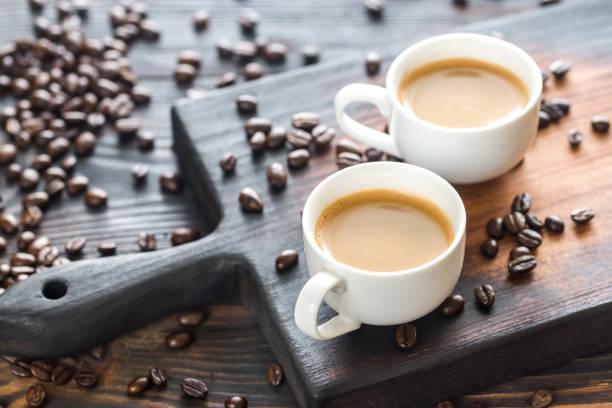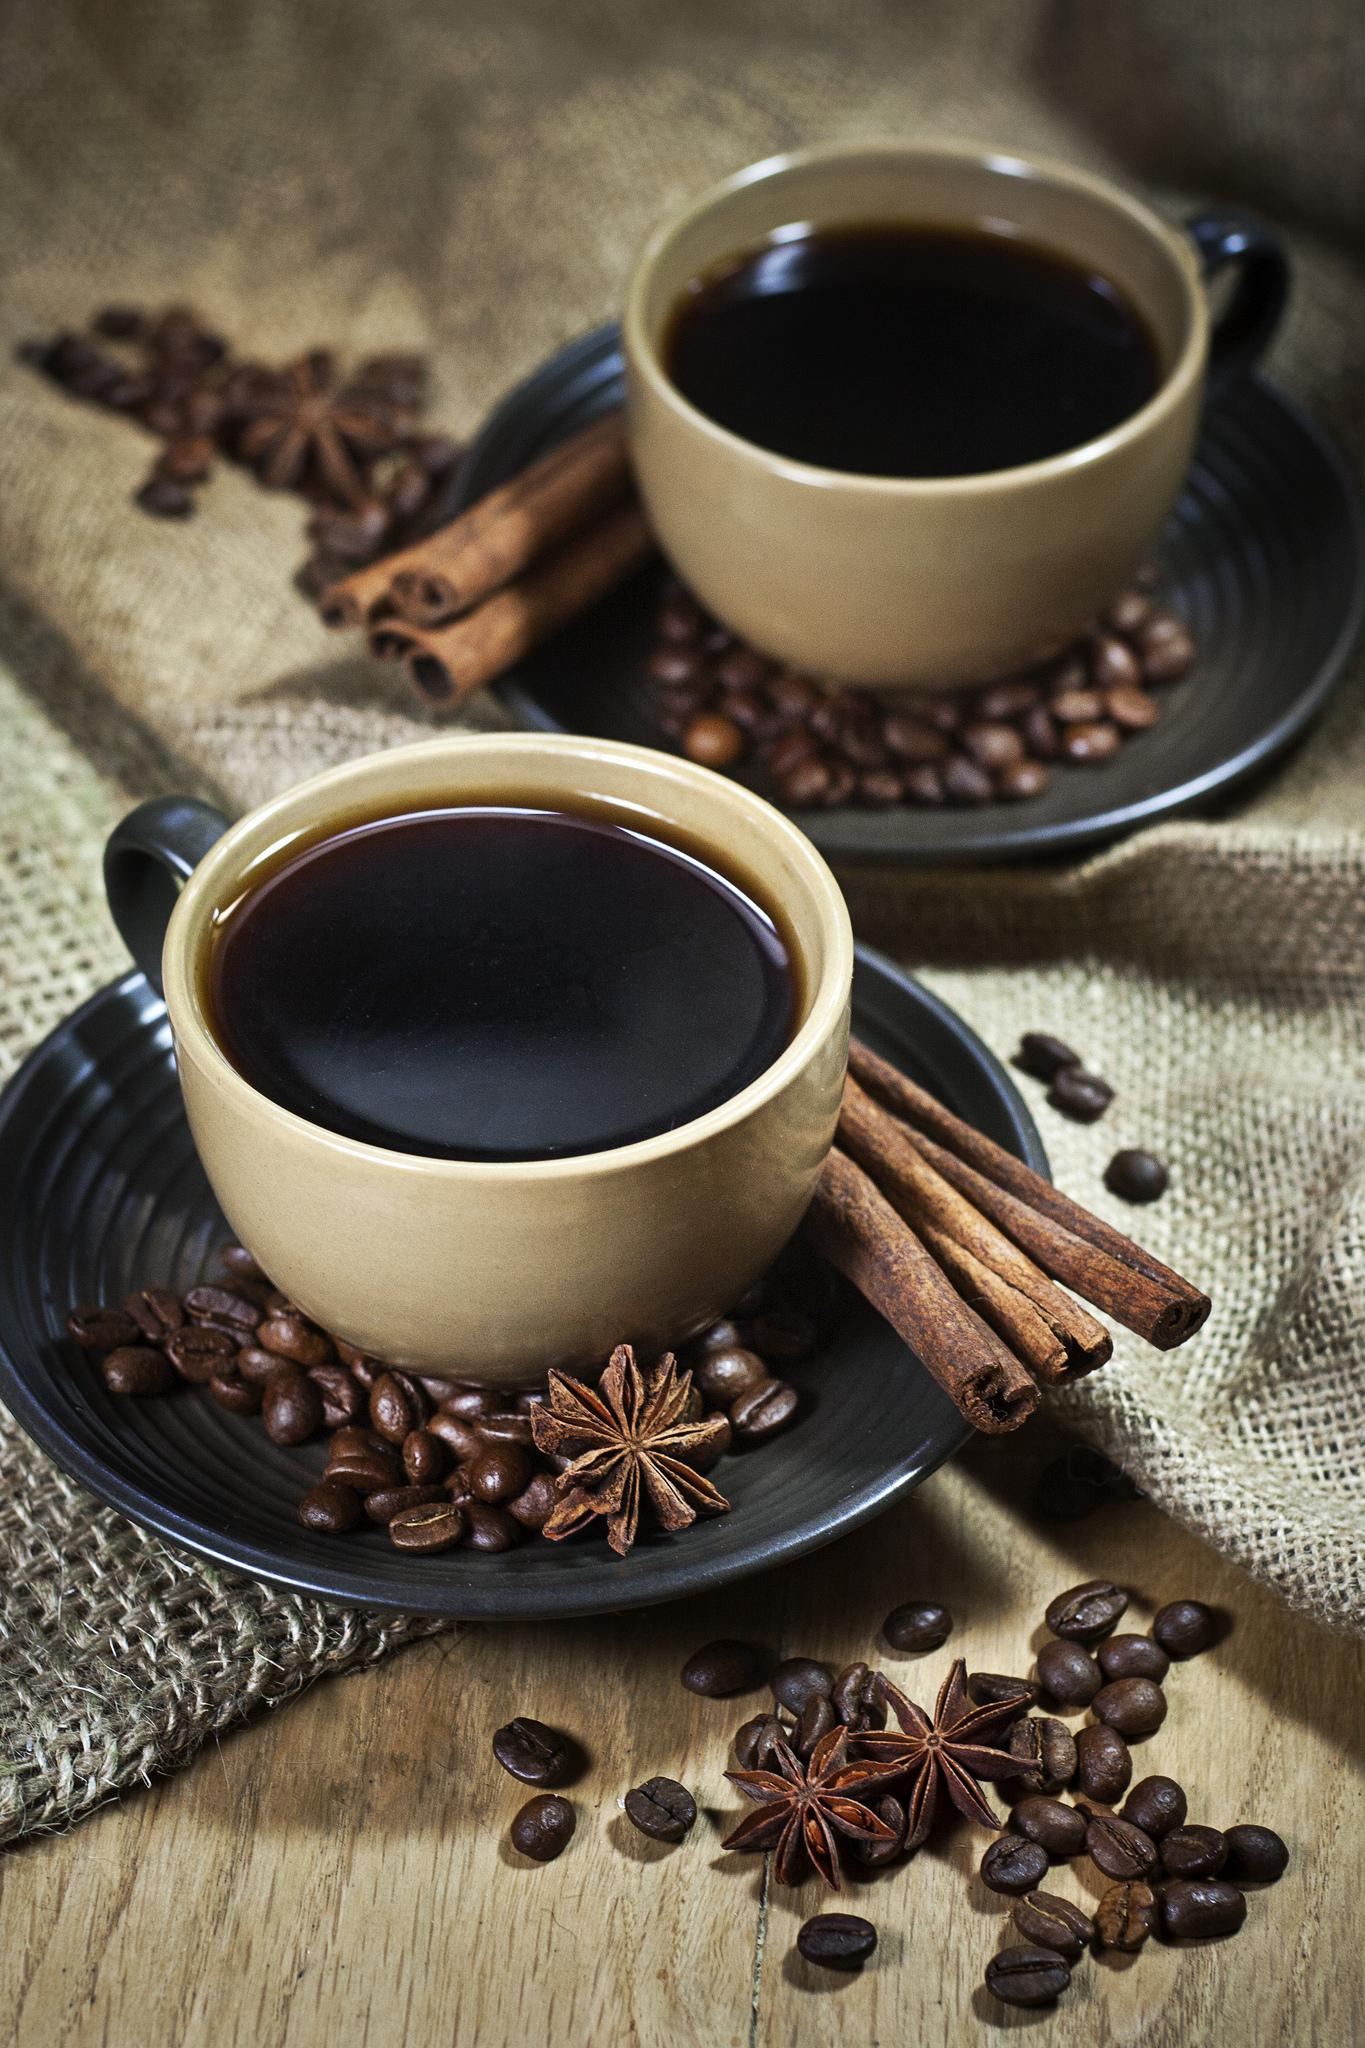The first image is the image on the left, the second image is the image on the right. Assess this claim about the two images: "An image shows one hot beverage in a cup on a saucer that holds a spoon.". Correct or not? Answer yes or no. No. The first image is the image on the left, the second image is the image on the right. Evaluate the accuracy of this statement regarding the images: "There are three cups of coffee on three saucers.". Is it true? Answer yes or no. No. 